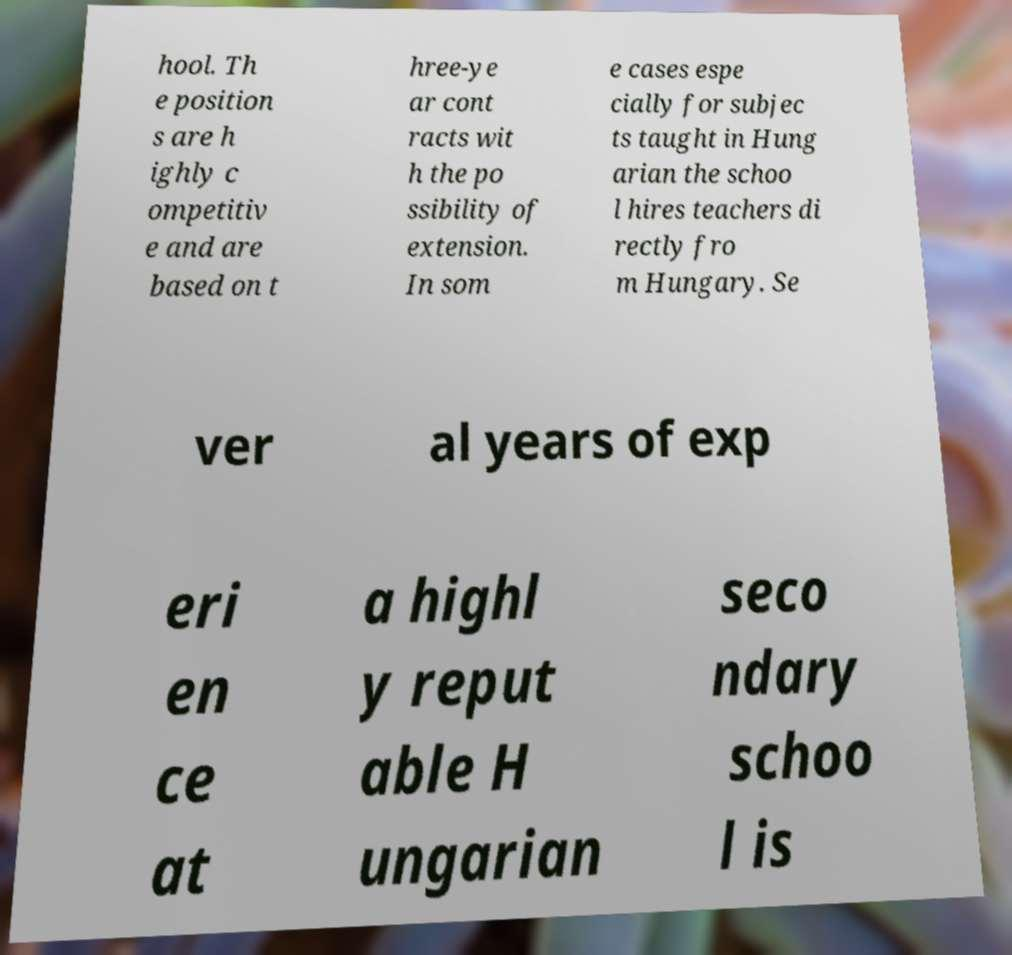Could you extract and type out the text from this image? hool. Th e position s are h ighly c ompetitiv e and are based on t hree-ye ar cont racts wit h the po ssibility of extension. In som e cases espe cially for subjec ts taught in Hung arian the schoo l hires teachers di rectly fro m Hungary. Se ver al years of exp eri en ce at a highl y reput able H ungarian seco ndary schoo l is 